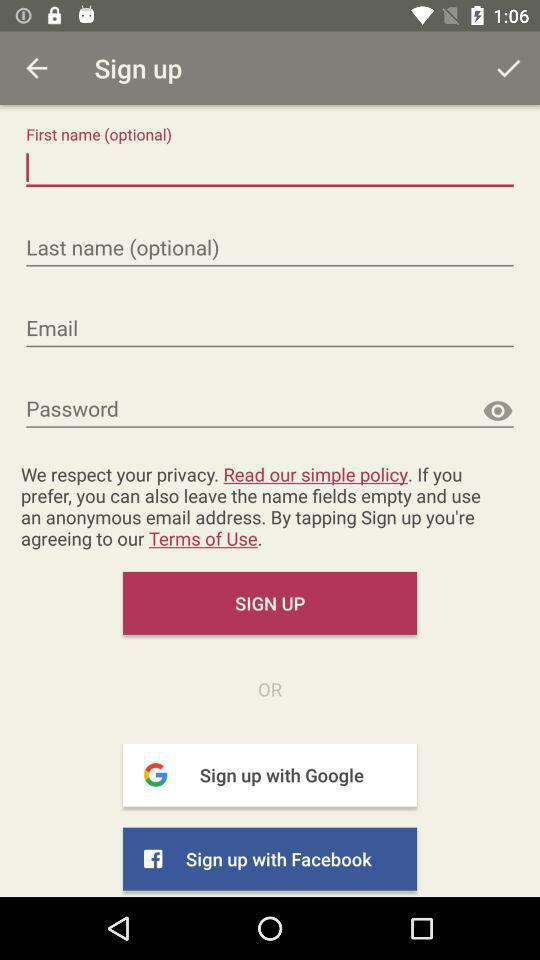What are the options for signing up? The options for signing up are "Email", "Google", and "Facebook". 